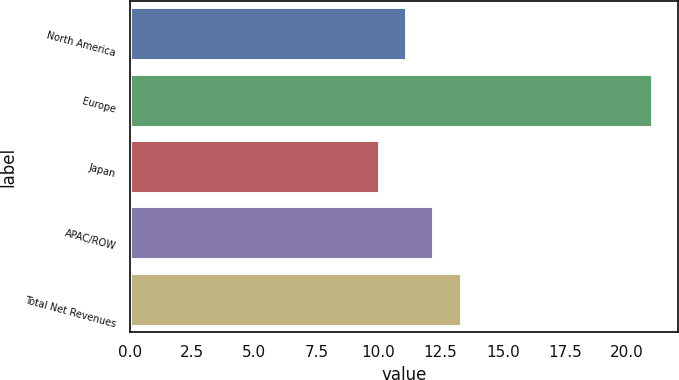Convert chart. <chart><loc_0><loc_0><loc_500><loc_500><bar_chart><fcel>North America<fcel>Europe<fcel>Japan<fcel>APAC/ROW<fcel>Total Net Revenues<nl><fcel>11.1<fcel>21<fcel>10<fcel>12.2<fcel>13.3<nl></chart> 